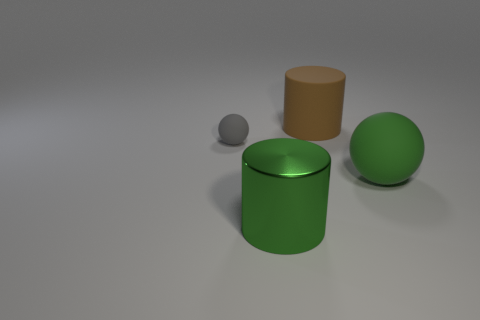What mood or atmosphere does the image convey? The image has a minimalist and clean aesthetic, conveying a calm and ordered atmosphere. The neutral background and evenly spaced objects could suggest a sense of harmony and simplicity. 